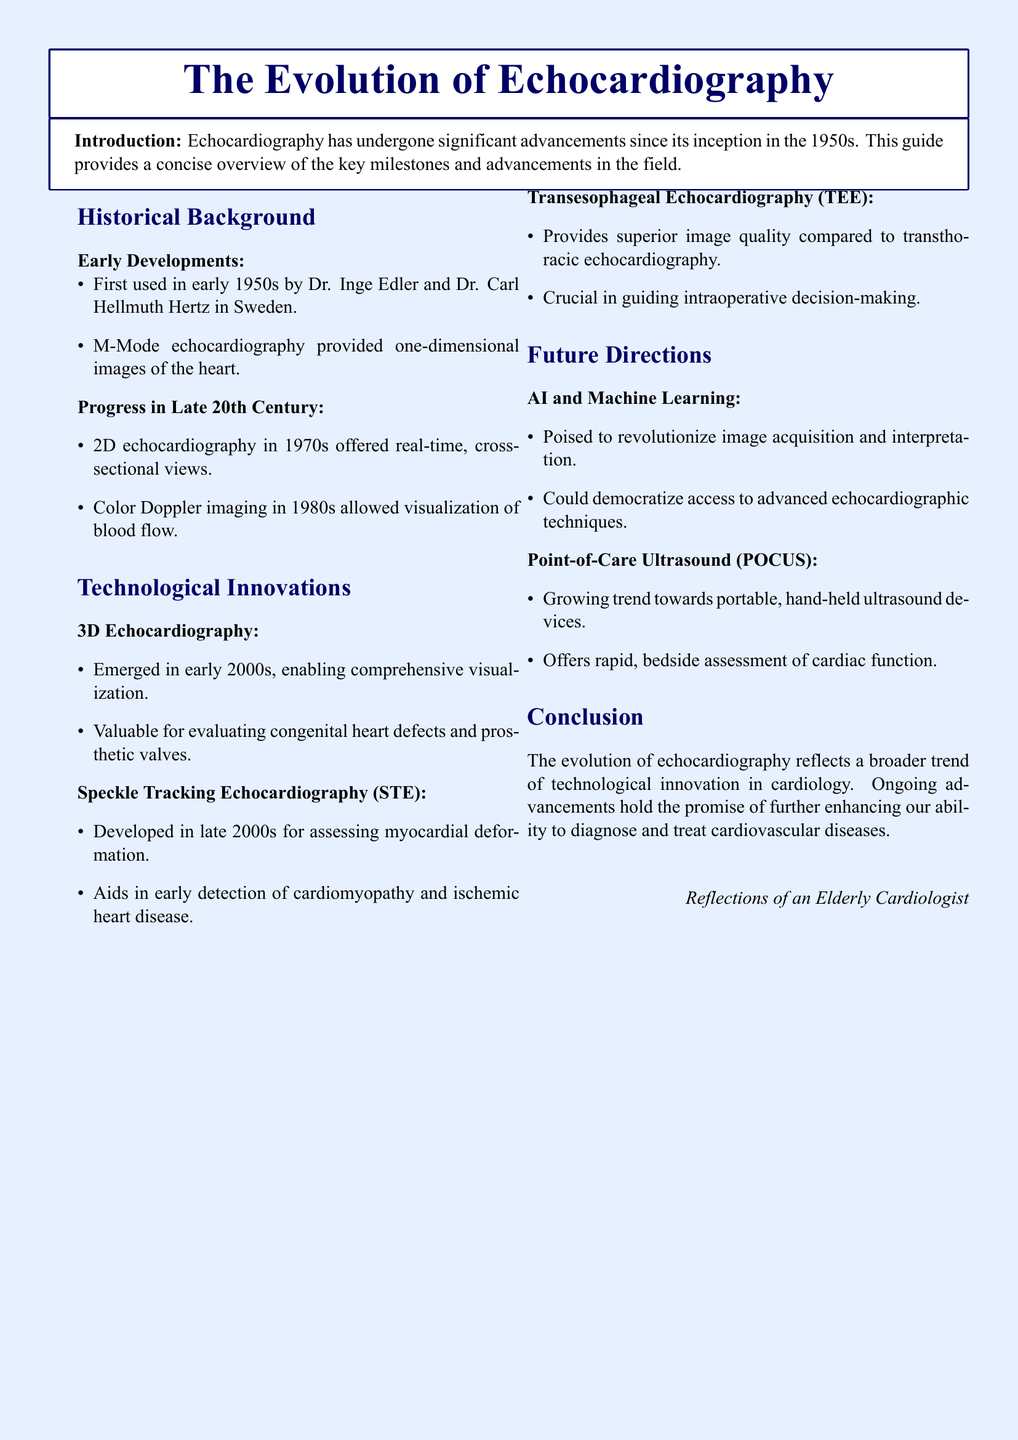What year did echocardiography first emerge? The document states that echocardiography was first used in the early 1950s.
Answer: 1950s Who were the pioneers of echocardiography? The document mentions Dr. Inge Edler and Dr. Carl Hellmuth Hertz as the first users of echocardiography.
Answer: Dr. Inge Edler and Dr. Carl Hellmuth Hertz What imaging advancement was introduced in the 1970s? According to the document, 2D echocardiography provided real-time, cross-sectional views in the 1970s.
Answer: 2D echocardiography What technique allows for visualization of blood flow? The document states that color Doppler imaging enabled the visualization of blood flow in the 1980s.
Answer: Color Doppler imaging When did 3D echocardiography emerge? The document indicates that 3D echocardiography emerged in the early 2000s.
Answer: Early 2000s What is the main benefit of transesophageal echocardiography? The document mentions that TEE provides superior image quality.
Answer: Superior image quality What technological trend is mentioned for the future of echocardiography? The document includes AI and machine learning as a trend poised to revolutionize echocardiography.
Answer: AI and machine learning What does POCUS stand for? The document refers to point-of-care ultrasound as POCUS.
Answer: Point-of-care ultrasound 